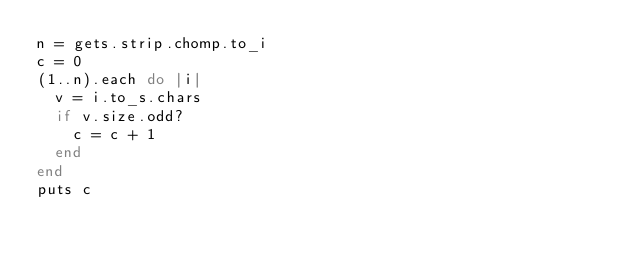Convert code to text. <code><loc_0><loc_0><loc_500><loc_500><_Ruby_>n = gets.strip.chomp.to_i
c = 0
(1..n).each do |i|
  v = i.to_s.chars
  if v.size.odd?
    c = c + 1
  end
end
puts c</code> 